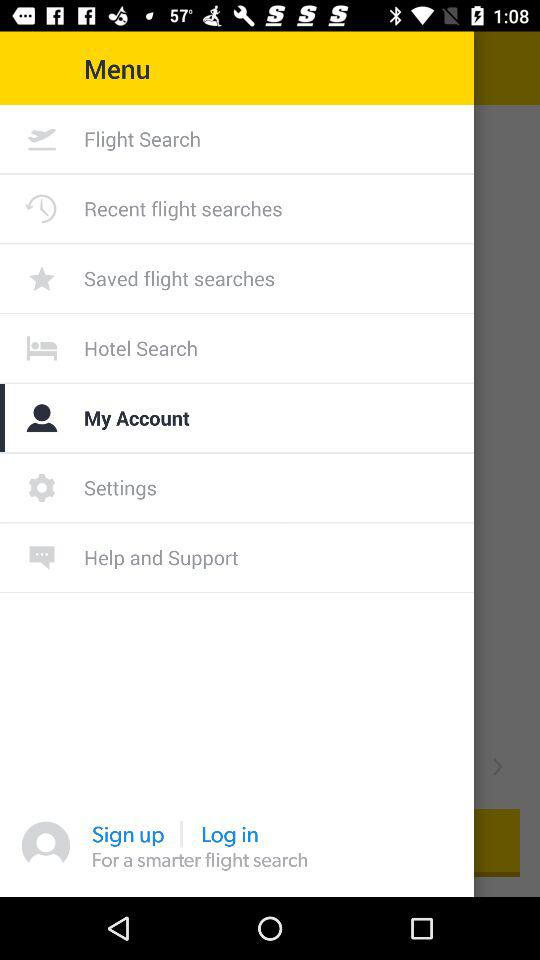Which item is selected? The selected item is "My Account". 